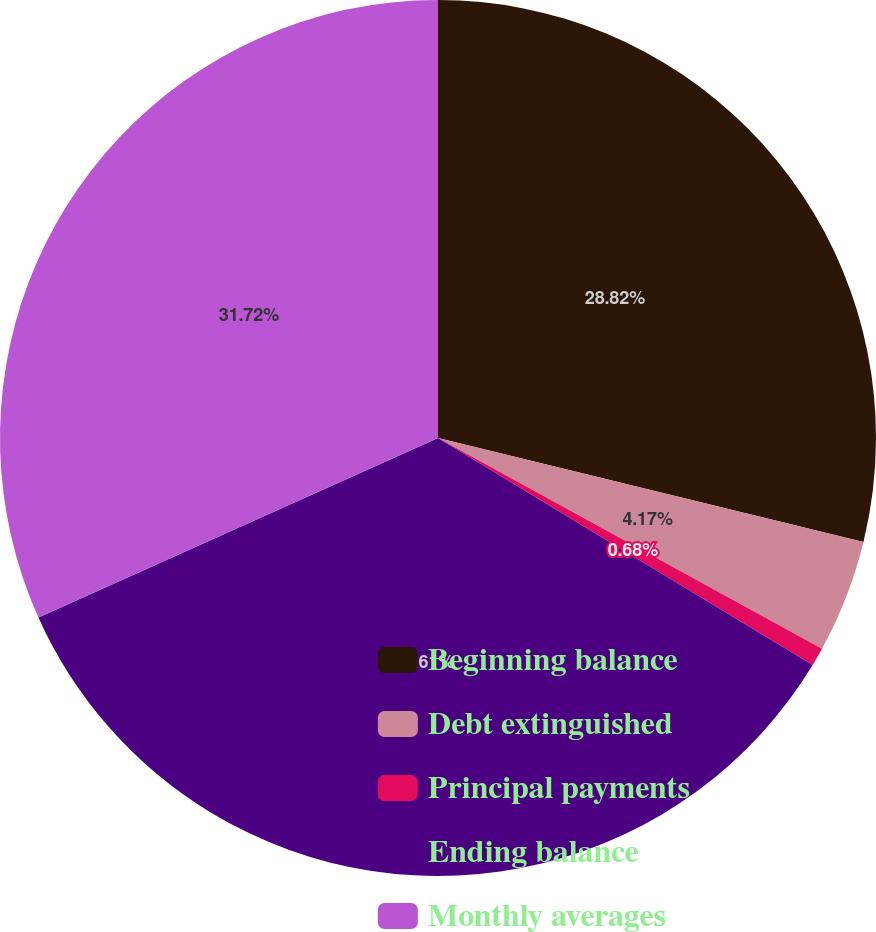Convert chart. <chart><loc_0><loc_0><loc_500><loc_500><pie_chart><fcel>Beginning balance<fcel>Debt extinguished<fcel>Principal payments<fcel>Ending balance<fcel>Monthly averages<nl><fcel>28.82%<fcel>4.17%<fcel>0.68%<fcel>34.62%<fcel>31.72%<nl></chart> 